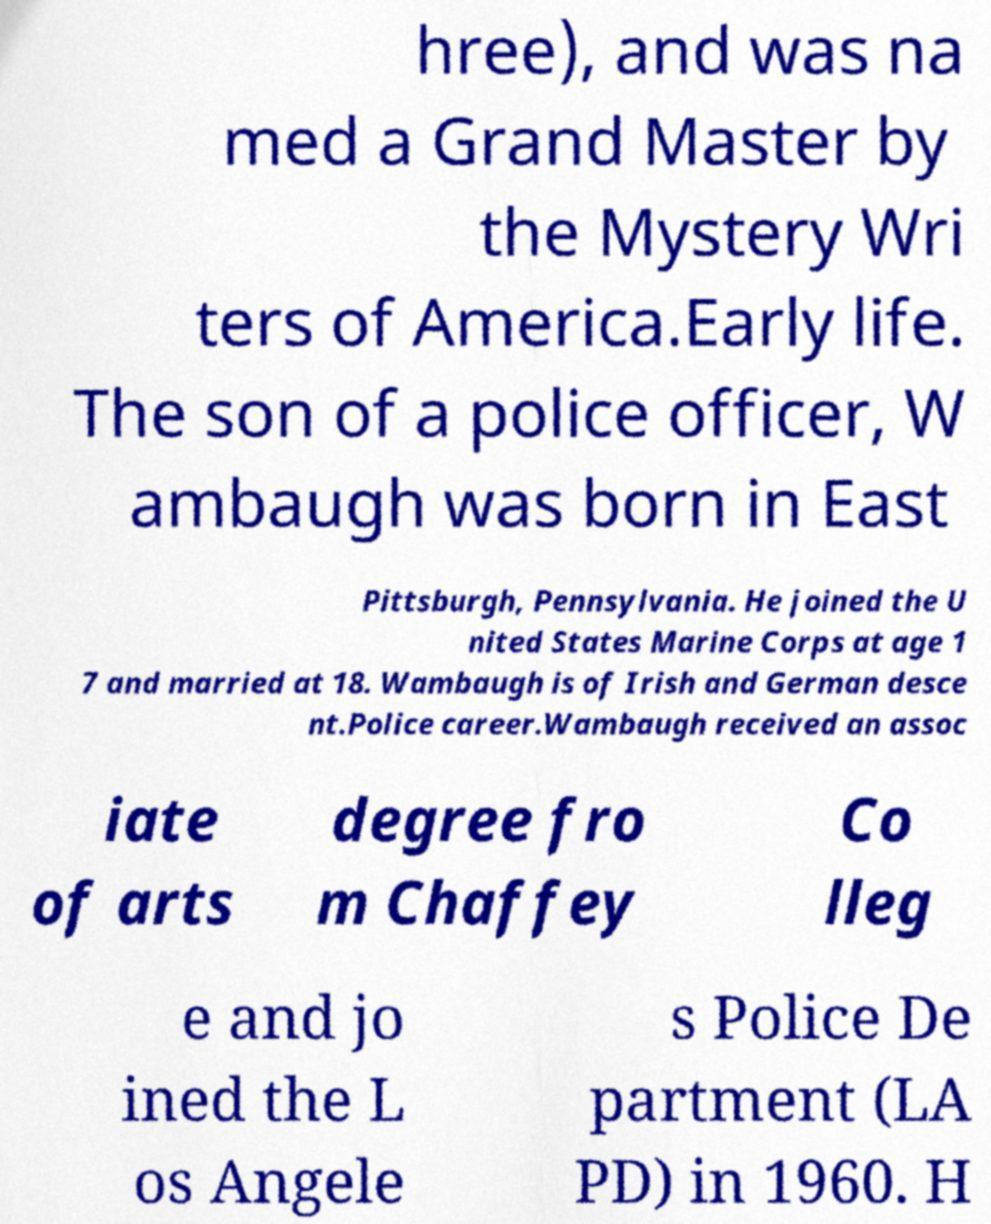I need the written content from this picture converted into text. Can you do that? hree), and was na med a Grand Master by the Mystery Wri ters of America.Early life. The son of a police officer, W ambaugh was born in East Pittsburgh, Pennsylvania. He joined the U nited States Marine Corps at age 1 7 and married at 18. Wambaugh is of Irish and German desce nt.Police career.Wambaugh received an assoc iate of arts degree fro m Chaffey Co lleg e and jo ined the L os Angele s Police De partment (LA PD) in 1960. H 